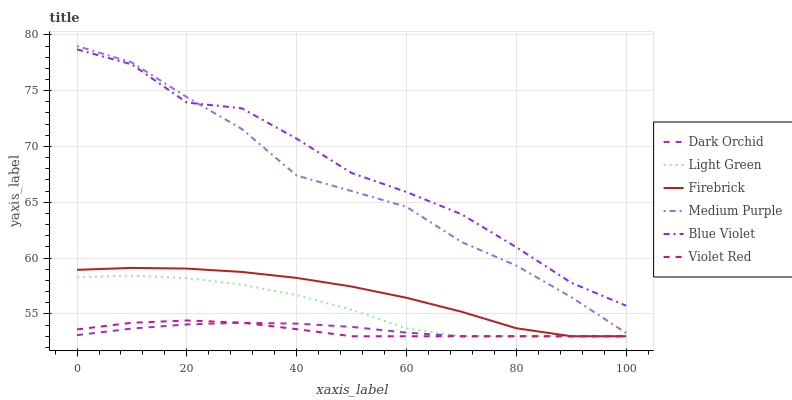Does Firebrick have the minimum area under the curve?
Answer yes or no. No. Does Firebrick have the maximum area under the curve?
Answer yes or no. No. Is Firebrick the smoothest?
Answer yes or no. No. Is Firebrick the roughest?
Answer yes or no. No. Does Medium Purple have the lowest value?
Answer yes or no. No. Does Firebrick have the highest value?
Answer yes or no. No. Is Firebrick less than Medium Purple?
Answer yes or no. Yes. Is Medium Purple greater than Firebrick?
Answer yes or no. Yes. Does Firebrick intersect Medium Purple?
Answer yes or no. No. 